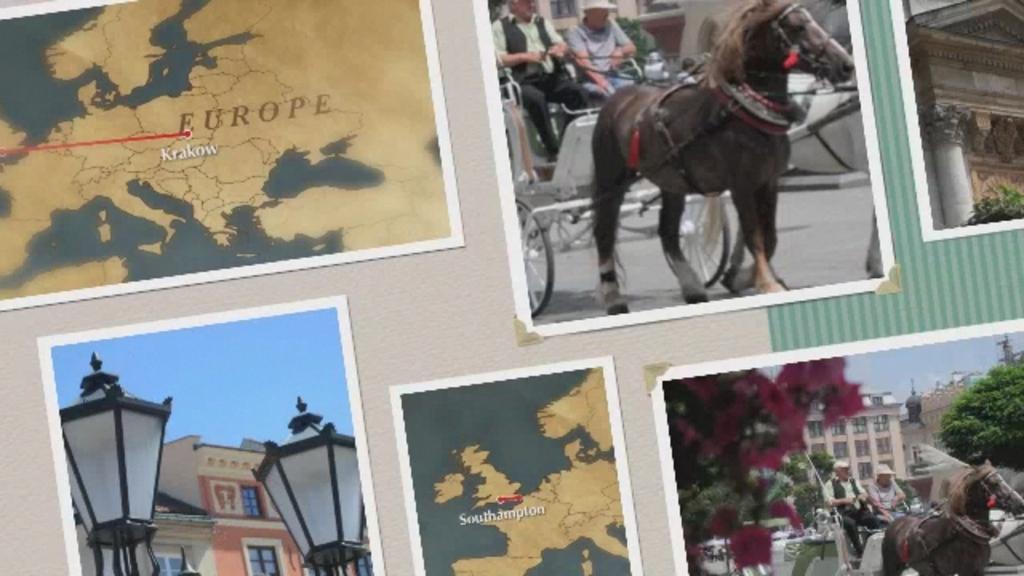Can you describe this image briefly? This is a collage image, in this image there are six photos, two photos are maps, two are horse cart two persons are riding horse cart, in one picture there is a building in another picture there are lights. 